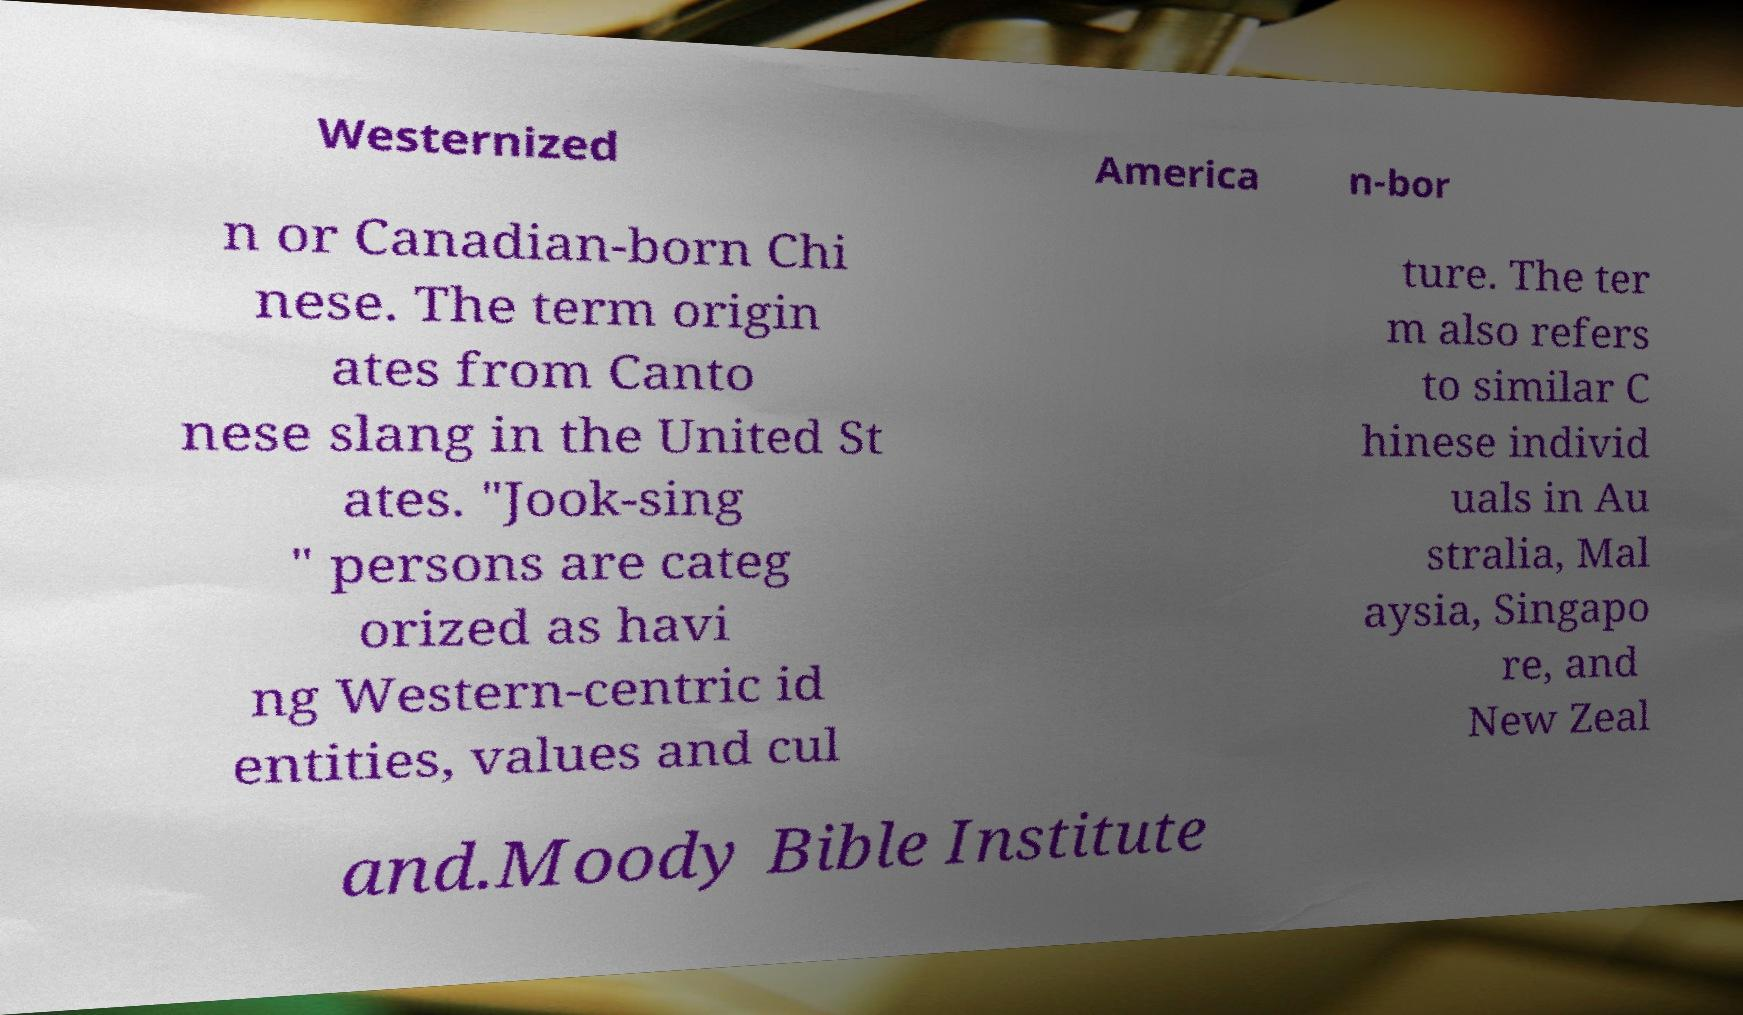For documentation purposes, I need the text within this image transcribed. Could you provide that? Westernized America n-bor n or Canadian-born Chi nese. The term origin ates from Canto nese slang in the United St ates. "Jook-sing " persons are categ orized as havi ng Western-centric id entities, values and cul ture. The ter m also refers to similar C hinese individ uals in Au stralia, Mal aysia, Singapo re, and New Zeal and.Moody Bible Institute 